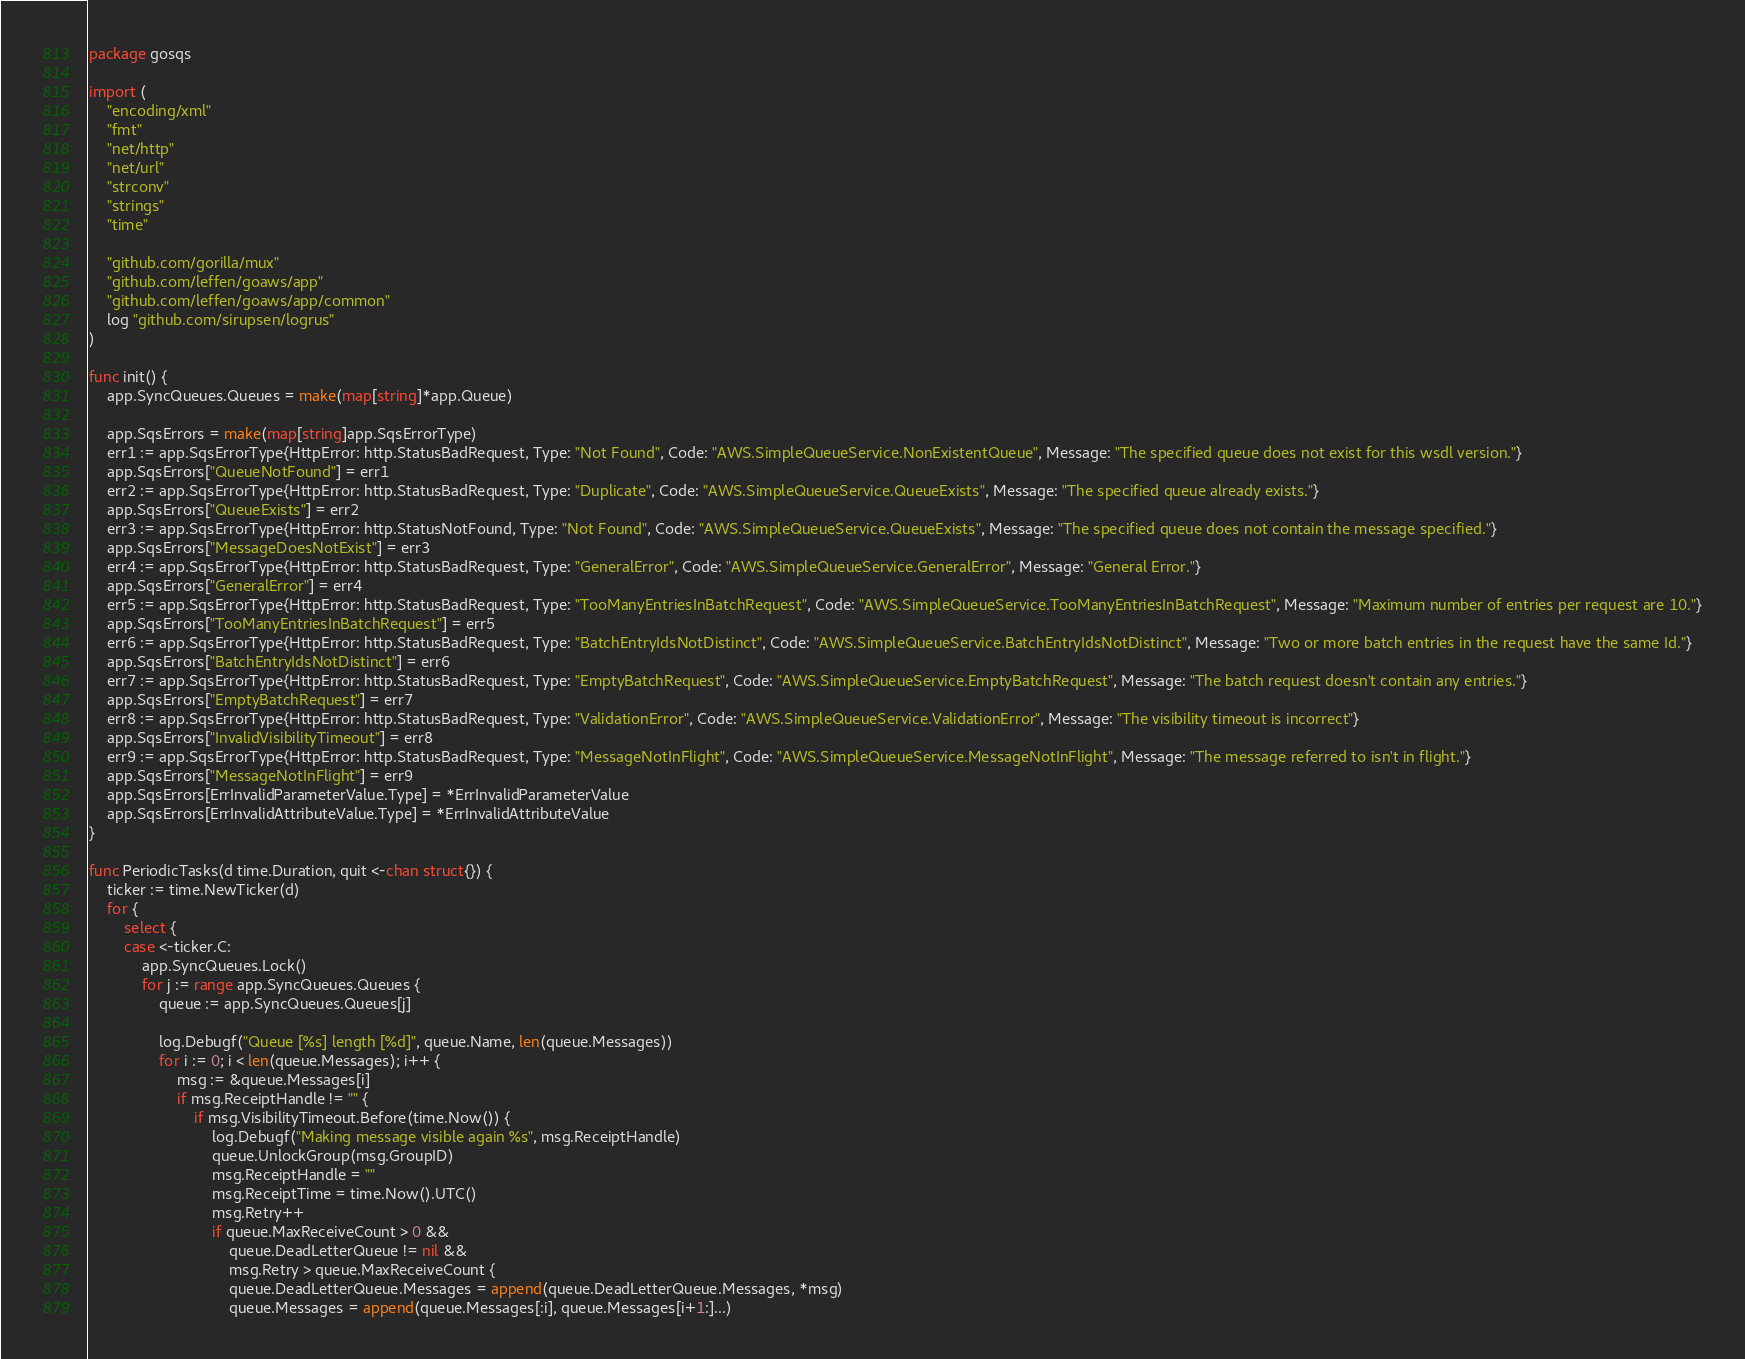Convert code to text. <code><loc_0><loc_0><loc_500><loc_500><_Go_>package gosqs

import (
	"encoding/xml"
	"fmt"
	"net/http"
	"net/url"
	"strconv"
	"strings"
	"time"

	"github.com/gorilla/mux"
	"github.com/leffen/goaws/app"
	"github.com/leffen/goaws/app/common"
	log "github.com/sirupsen/logrus"
)

func init() {
	app.SyncQueues.Queues = make(map[string]*app.Queue)

	app.SqsErrors = make(map[string]app.SqsErrorType)
	err1 := app.SqsErrorType{HttpError: http.StatusBadRequest, Type: "Not Found", Code: "AWS.SimpleQueueService.NonExistentQueue", Message: "The specified queue does not exist for this wsdl version."}
	app.SqsErrors["QueueNotFound"] = err1
	err2 := app.SqsErrorType{HttpError: http.StatusBadRequest, Type: "Duplicate", Code: "AWS.SimpleQueueService.QueueExists", Message: "The specified queue already exists."}
	app.SqsErrors["QueueExists"] = err2
	err3 := app.SqsErrorType{HttpError: http.StatusNotFound, Type: "Not Found", Code: "AWS.SimpleQueueService.QueueExists", Message: "The specified queue does not contain the message specified."}
	app.SqsErrors["MessageDoesNotExist"] = err3
	err4 := app.SqsErrorType{HttpError: http.StatusBadRequest, Type: "GeneralError", Code: "AWS.SimpleQueueService.GeneralError", Message: "General Error."}
	app.SqsErrors["GeneralError"] = err4
	err5 := app.SqsErrorType{HttpError: http.StatusBadRequest, Type: "TooManyEntriesInBatchRequest", Code: "AWS.SimpleQueueService.TooManyEntriesInBatchRequest", Message: "Maximum number of entries per request are 10."}
	app.SqsErrors["TooManyEntriesInBatchRequest"] = err5
	err6 := app.SqsErrorType{HttpError: http.StatusBadRequest, Type: "BatchEntryIdsNotDistinct", Code: "AWS.SimpleQueueService.BatchEntryIdsNotDistinct", Message: "Two or more batch entries in the request have the same Id."}
	app.SqsErrors["BatchEntryIdsNotDistinct"] = err6
	err7 := app.SqsErrorType{HttpError: http.StatusBadRequest, Type: "EmptyBatchRequest", Code: "AWS.SimpleQueueService.EmptyBatchRequest", Message: "The batch request doesn't contain any entries."}
	app.SqsErrors["EmptyBatchRequest"] = err7
	err8 := app.SqsErrorType{HttpError: http.StatusBadRequest, Type: "ValidationError", Code: "AWS.SimpleQueueService.ValidationError", Message: "The visibility timeout is incorrect"}
	app.SqsErrors["InvalidVisibilityTimeout"] = err8
	err9 := app.SqsErrorType{HttpError: http.StatusBadRequest, Type: "MessageNotInFlight", Code: "AWS.SimpleQueueService.MessageNotInFlight", Message: "The message referred to isn't in flight."}
	app.SqsErrors["MessageNotInFlight"] = err9
	app.SqsErrors[ErrInvalidParameterValue.Type] = *ErrInvalidParameterValue
	app.SqsErrors[ErrInvalidAttributeValue.Type] = *ErrInvalidAttributeValue
}

func PeriodicTasks(d time.Duration, quit <-chan struct{}) {
	ticker := time.NewTicker(d)
	for {
		select {
		case <-ticker.C:
			app.SyncQueues.Lock()
			for j := range app.SyncQueues.Queues {
				queue := app.SyncQueues.Queues[j]

				log.Debugf("Queue [%s] length [%d]", queue.Name, len(queue.Messages))
				for i := 0; i < len(queue.Messages); i++ {
					msg := &queue.Messages[i]
					if msg.ReceiptHandle != "" {
						if msg.VisibilityTimeout.Before(time.Now()) {
							log.Debugf("Making message visible again %s", msg.ReceiptHandle)
							queue.UnlockGroup(msg.GroupID)
							msg.ReceiptHandle = ""
							msg.ReceiptTime = time.Now().UTC()
							msg.Retry++
							if queue.MaxReceiveCount > 0 &&
								queue.DeadLetterQueue != nil &&
								msg.Retry > queue.MaxReceiveCount {
								queue.DeadLetterQueue.Messages = append(queue.DeadLetterQueue.Messages, *msg)
								queue.Messages = append(queue.Messages[:i], queue.Messages[i+1:]...)</code> 